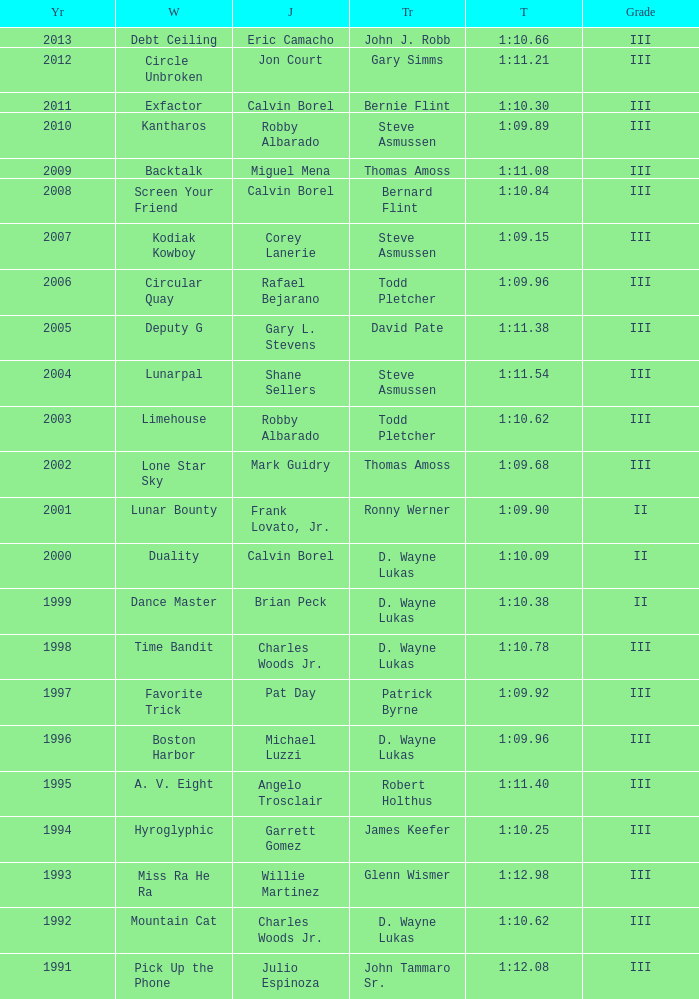Who won under Gary Simms? Circle Unbroken. Help me parse the entirety of this table. {'header': ['Yr', 'W', 'J', 'Tr', 'T', 'Grade'], 'rows': [['2013', 'Debt Ceiling', 'Eric Camacho', 'John J. Robb', '1:10.66', 'III'], ['2012', 'Circle Unbroken', 'Jon Court', 'Gary Simms', '1:11.21', 'III'], ['2011', 'Exfactor', 'Calvin Borel', 'Bernie Flint', '1:10.30', 'III'], ['2010', 'Kantharos', 'Robby Albarado', 'Steve Asmussen', '1:09.89', 'III'], ['2009', 'Backtalk', 'Miguel Mena', 'Thomas Amoss', '1:11.08', 'III'], ['2008', 'Screen Your Friend', 'Calvin Borel', 'Bernard Flint', '1:10.84', 'III'], ['2007', 'Kodiak Kowboy', 'Corey Lanerie', 'Steve Asmussen', '1:09.15', 'III'], ['2006', 'Circular Quay', 'Rafael Bejarano', 'Todd Pletcher', '1:09.96', 'III'], ['2005', 'Deputy G', 'Gary L. Stevens', 'David Pate', '1:11.38', 'III'], ['2004', 'Lunarpal', 'Shane Sellers', 'Steve Asmussen', '1:11.54', 'III'], ['2003', 'Limehouse', 'Robby Albarado', 'Todd Pletcher', '1:10.62', 'III'], ['2002', 'Lone Star Sky', 'Mark Guidry', 'Thomas Amoss', '1:09.68', 'III'], ['2001', 'Lunar Bounty', 'Frank Lovato, Jr.', 'Ronny Werner', '1:09.90', 'II'], ['2000', 'Duality', 'Calvin Borel', 'D. Wayne Lukas', '1:10.09', 'II'], ['1999', 'Dance Master', 'Brian Peck', 'D. Wayne Lukas', '1:10.38', 'II'], ['1998', 'Time Bandit', 'Charles Woods Jr.', 'D. Wayne Lukas', '1:10.78', 'III'], ['1997', 'Favorite Trick', 'Pat Day', 'Patrick Byrne', '1:09.92', 'III'], ['1996', 'Boston Harbor', 'Michael Luzzi', 'D. Wayne Lukas', '1:09.96', 'III'], ['1995', 'A. V. Eight', 'Angelo Trosclair', 'Robert Holthus', '1:11.40', 'III'], ['1994', 'Hyroglyphic', 'Garrett Gomez', 'James Keefer', '1:10.25', 'III'], ['1993', 'Miss Ra He Ra', 'Willie Martinez', 'Glenn Wismer', '1:12.98', 'III'], ['1992', 'Mountain Cat', 'Charles Woods Jr.', 'D. Wayne Lukas', '1:10.62', 'III'], ['1991', 'Pick Up the Phone', 'Julio Espinoza', 'John Tammaro Sr.', '1:12.08', 'III']]} 